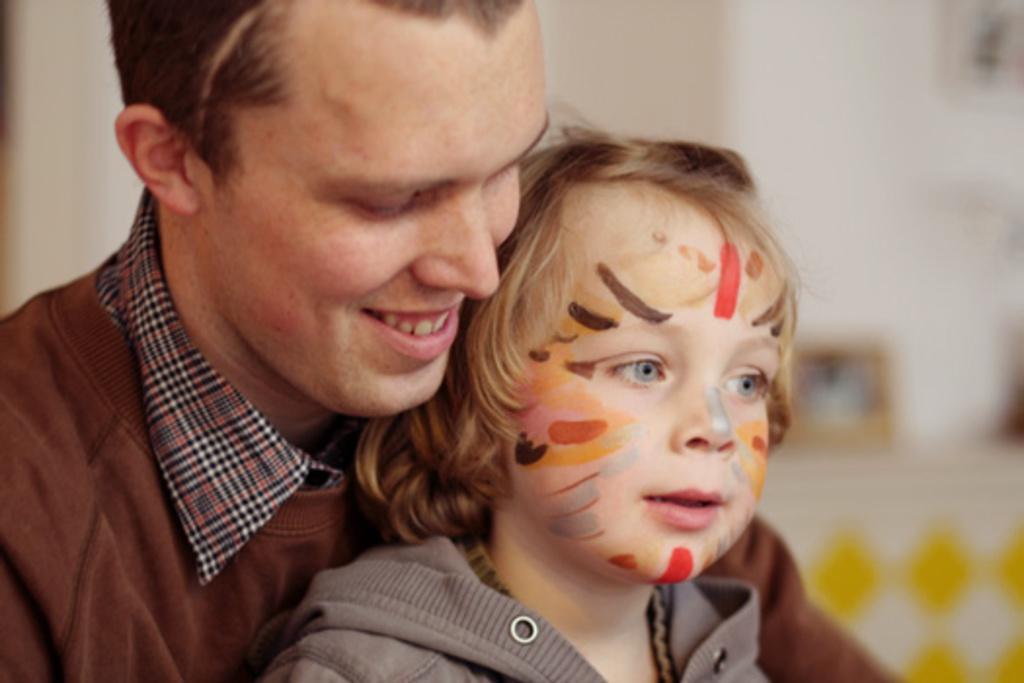Could you give a brief overview of what you see in this image? In this image we can see a man and the child. On the backside we can see some objects on a table and a wall. 